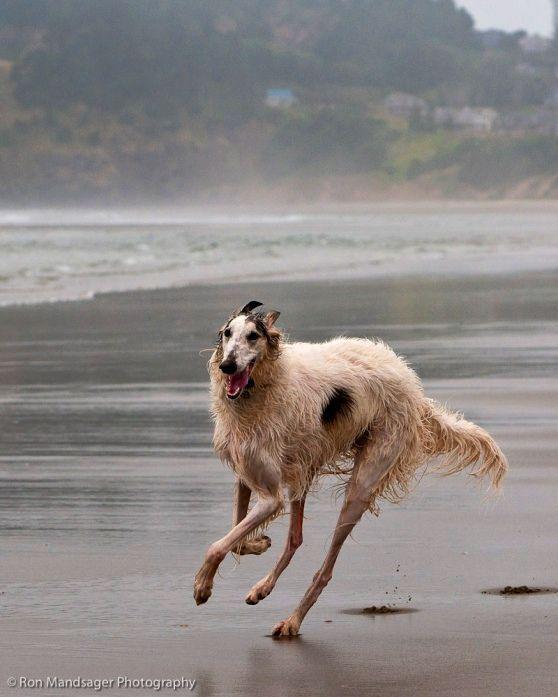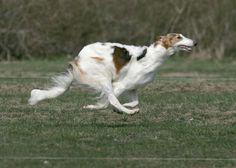The first image is the image on the left, the second image is the image on the right. Assess this claim about the two images: "Each image features one bounding dog, with one image showing a dog on a beach and the other a dog on a grassy field.". Correct or not? Answer yes or no. Yes. The first image is the image on the left, the second image is the image on the right. Examine the images to the left and right. Is the description "The right image contains at least one dog that is surrounded by snow." accurate? Answer yes or no. No. 